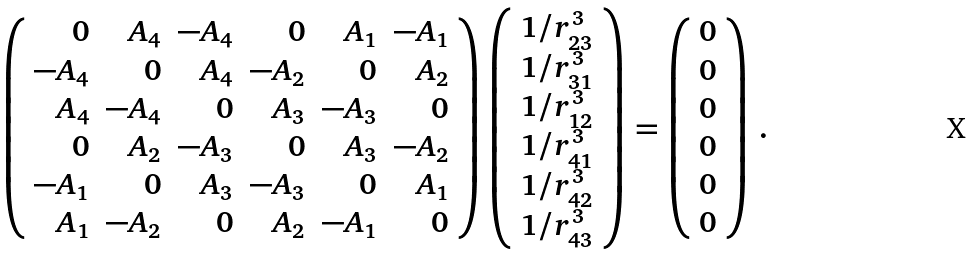Convert formula to latex. <formula><loc_0><loc_0><loc_500><loc_500>\left ( \begin{array} { r r r r r r } 0 & A _ { 4 } & - A _ { 4 } & 0 & A _ { 1 } & - A _ { 1 } \\ - A _ { 4 } & 0 & A _ { 4 } & - A _ { 2 } & 0 & A _ { 2 } \\ A _ { 4 } & - A _ { 4 } & 0 & A _ { 3 } & - A _ { 3 } & 0 \\ 0 & A _ { 2 } & - A _ { 3 } & 0 & A _ { 3 } & - A _ { 2 } \\ - A _ { 1 } & 0 & A _ { 3 } & - A _ { 3 } & 0 & A _ { 1 } \\ A _ { 1 } & - A _ { 2 } & 0 & A _ { 2 } & - A _ { 1 } & 0 \end{array} \right ) \left ( \begin{array} { c } 1 / r _ { 2 3 } ^ { 3 } \\ 1 / r _ { 3 1 } ^ { 3 } \\ 1 / r _ { 1 2 } ^ { 3 } \\ 1 / r _ { 4 1 } ^ { 3 } \\ 1 / r _ { 4 2 } ^ { 3 } \\ 1 / r _ { 4 3 } ^ { 3 } \end{array} \right ) = \left ( \begin{array} { c } 0 \\ 0 \\ 0 \\ 0 \\ 0 \\ 0 \end{array} \right ) \, .</formula> 